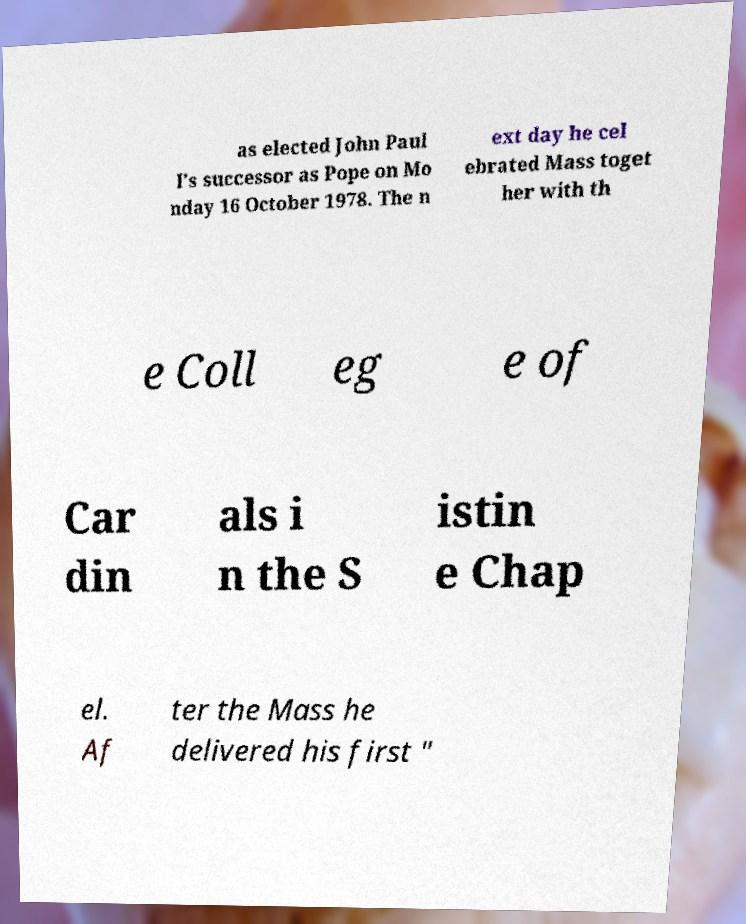Please identify and transcribe the text found in this image. as elected John Paul I's successor as Pope on Mo nday 16 October 1978. The n ext day he cel ebrated Mass toget her with th e Coll eg e of Car din als i n the S istin e Chap el. Af ter the Mass he delivered his first " 